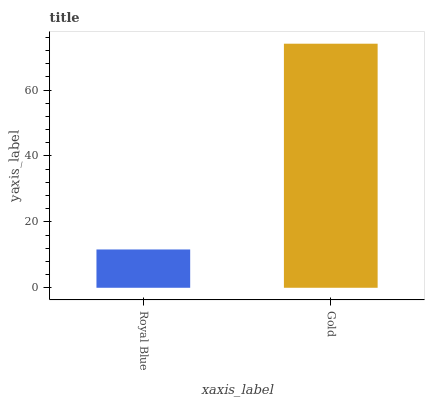Is Royal Blue the minimum?
Answer yes or no. Yes. Is Gold the maximum?
Answer yes or no. Yes. Is Gold the minimum?
Answer yes or no. No. Is Gold greater than Royal Blue?
Answer yes or no. Yes. Is Royal Blue less than Gold?
Answer yes or no. Yes. Is Royal Blue greater than Gold?
Answer yes or no. No. Is Gold less than Royal Blue?
Answer yes or no. No. Is Gold the high median?
Answer yes or no. Yes. Is Royal Blue the low median?
Answer yes or no. Yes. Is Royal Blue the high median?
Answer yes or no. No. Is Gold the low median?
Answer yes or no. No. 